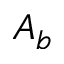<formula> <loc_0><loc_0><loc_500><loc_500>A _ { b }</formula> 